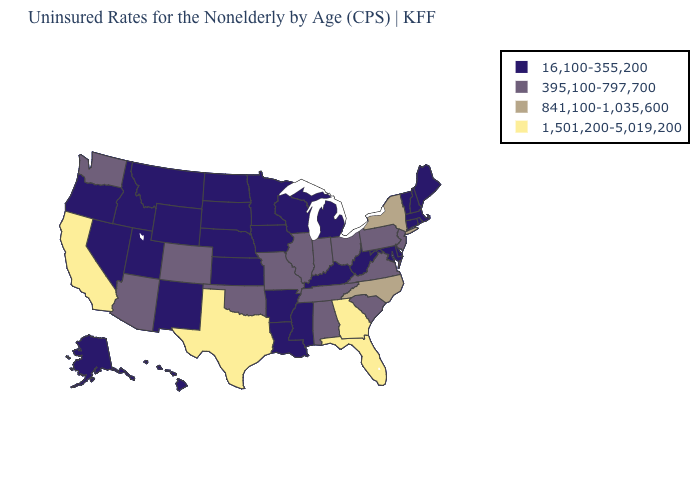What is the highest value in the South ?
Keep it brief. 1,501,200-5,019,200. Does Washington have a higher value than Arizona?
Quick response, please. No. Which states have the highest value in the USA?
Quick response, please. California, Florida, Georgia, Texas. What is the value of Utah?
Concise answer only. 16,100-355,200. Does Ohio have a higher value than Pennsylvania?
Give a very brief answer. No. What is the lowest value in states that border South Carolina?
Keep it brief. 841,100-1,035,600. How many symbols are there in the legend?
Concise answer only. 4. Does New Mexico have a lower value than Minnesota?
Keep it brief. No. Does Texas have the highest value in the USA?
Concise answer only. Yes. What is the lowest value in states that border Arkansas?
Concise answer only. 16,100-355,200. What is the lowest value in states that border Arkansas?
Give a very brief answer. 16,100-355,200. Name the states that have a value in the range 1,501,200-5,019,200?
Be succinct. California, Florida, Georgia, Texas. Among the states that border Massachusetts , which have the highest value?
Give a very brief answer. New York. What is the value of Connecticut?
Short answer required. 16,100-355,200. Among the states that border Tennessee , does Georgia have the highest value?
Give a very brief answer. Yes. 